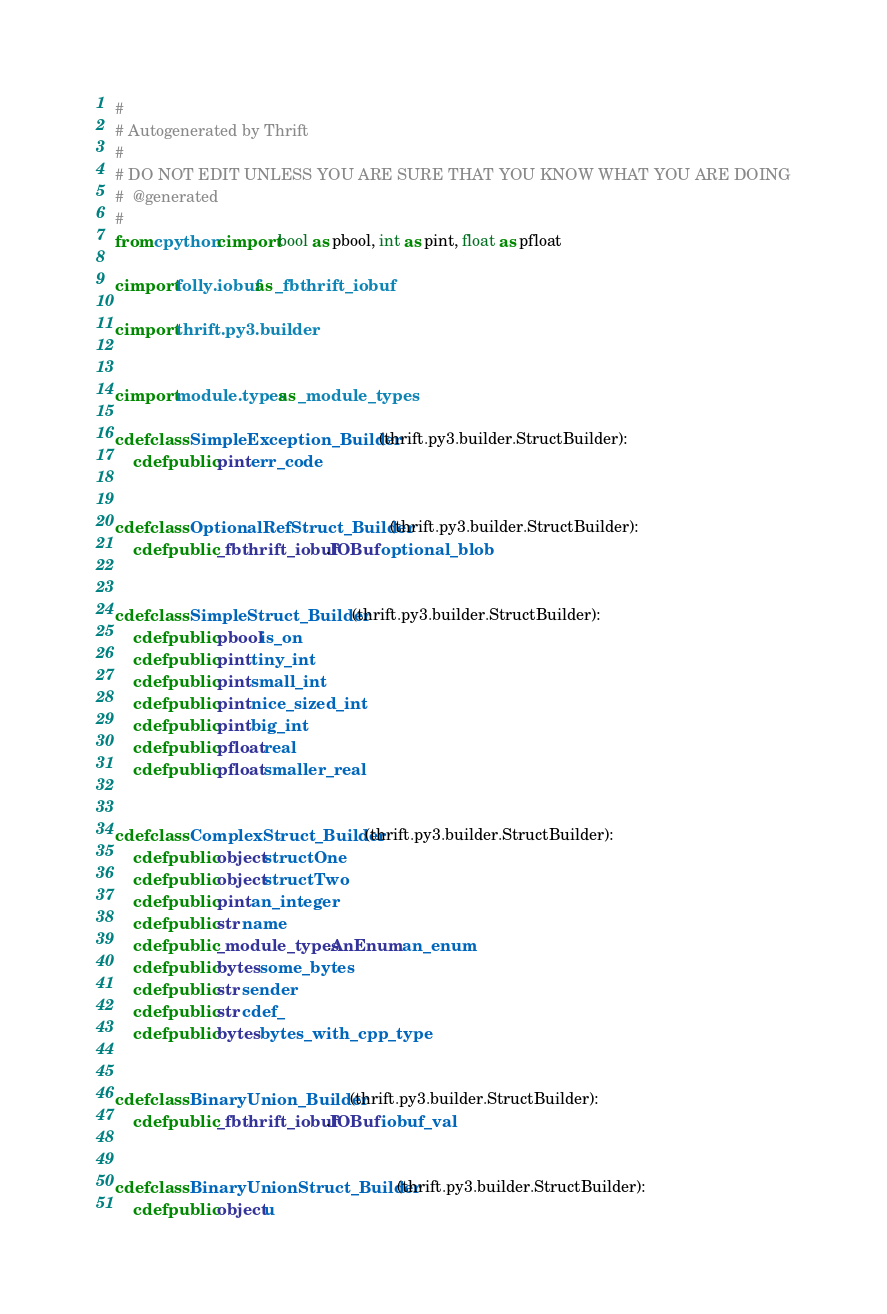Convert code to text. <code><loc_0><loc_0><loc_500><loc_500><_Cython_>#
# Autogenerated by Thrift
#
# DO NOT EDIT UNLESS YOU ARE SURE THAT YOU KNOW WHAT YOU ARE DOING
#  @generated
#
from cpython cimport bool as pbool, int as pint, float as pfloat

cimport folly.iobuf as _fbthrift_iobuf

cimport thrift.py3.builder


cimport module.types as _module_types

cdef class SimpleException_Builder(thrift.py3.builder.StructBuilder):
    cdef public pint err_code


cdef class OptionalRefStruct_Builder(thrift.py3.builder.StructBuilder):
    cdef public _fbthrift_iobuf.IOBuf optional_blob


cdef class SimpleStruct_Builder(thrift.py3.builder.StructBuilder):
    cdef public pbool is_on
    cdef public pint tiny_int
    cdef public pint small_int
    cdef public pint nice_sized_int
    cdef public pint big_int
    cdef public pfloat real
    cdef public pfloat smaller_real


cdef class ComplexStruct_Builder(thrift.py3.builder.StructBuilder):
    cdef public object structOne
    cdef public object structTwo
    cdef public pint an_integer
    cdef public str name
    cdef public _module_types.AnEnum an_enum
    cdef public bytes some_bytes
    cdef public str sender
    cdef public str cdef_
    cdef public bytes bytes_with_cpp_type


cdef class BinaryUnion_Builder(thrift.py3.builder.StructBuilder):
    cdef public _fbthrift_iobuf.IOBuf iobuf_val


cdef class BinaryUnionStruct_Builder(thrift.py3.builder.StructBuilder):
    cdef public object u


</code> 